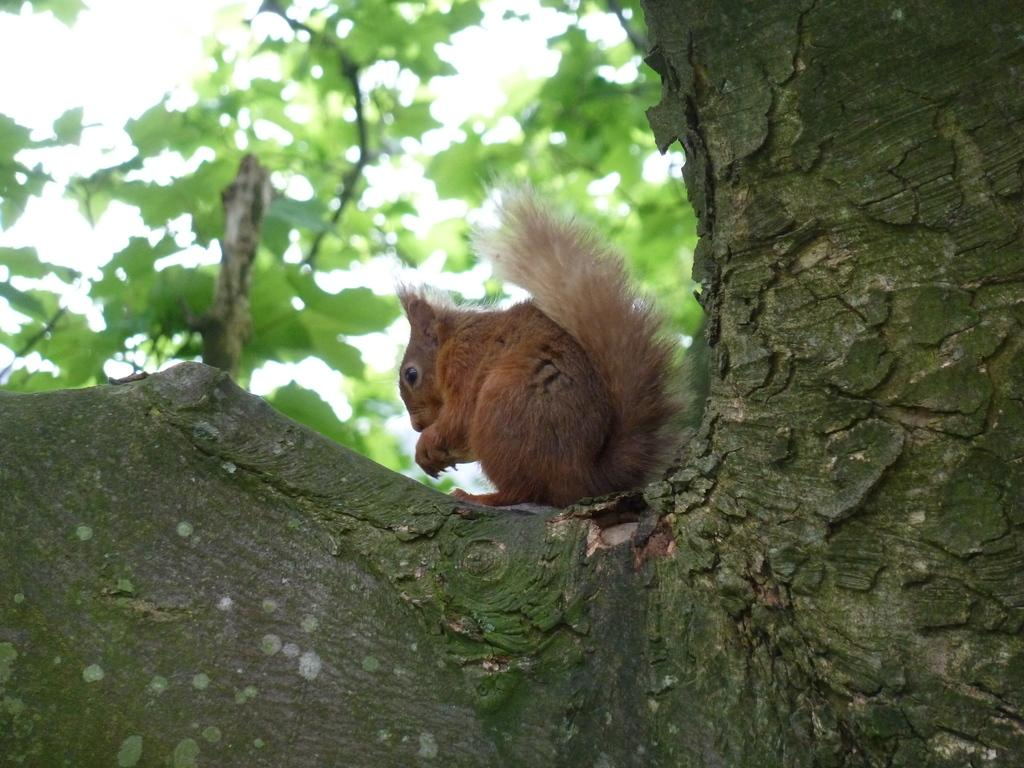What animal is present in the image? There is a squirrel in the image. Where is the squirrel located? The squirrel is on a tree branch. Can you describe the background of the image? The background of the image is blurred and green. What type of stitch is the squirrel using to climb the tree branch in the image? The squirrel is not using any stitch to climb the tree branch; it is using its claws and agility to move along the branch. 